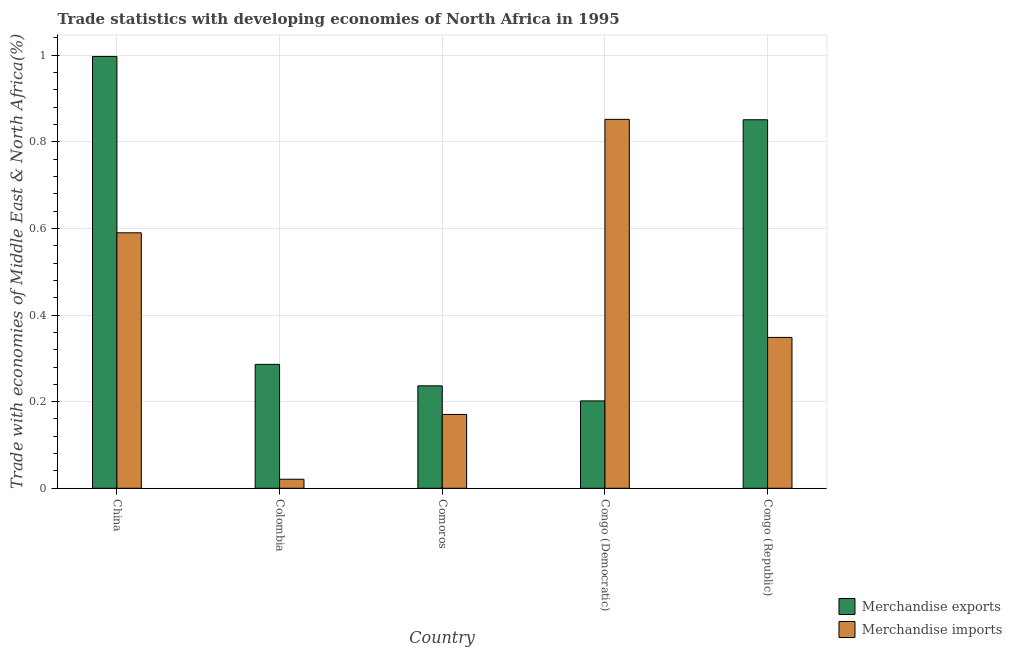How many different coloured bars are there?
Provide a short and direct response. 2. Are the number of bars on each tick of the X-axis equal?
Give a very brief answer. Yes. In how many cases, is the number of bars for a given country not equal to the number of legend labels?
Your answer should be very brief. 0. What is the merchandise exports in Comoros?
Give a very brief answer. 0.24. Across all countries, what is the maximum merchandise imports?
Make the answer very short. 0.85. Across all countries, what is the minimum merchandise imports?
Your answer should be very brief. 0.02. In which country was the merchandise imports maximum?
Provide a succinct answer. Congo (Democratic). In which country was the merchandise exports minimum?
Offer a terse response. Congo (Democratic). What is the total merchandise exports in the graph?
Ensure brevity in your answer.  2.57. What is the difference between the merchandise imports in China and that in Congo (Republic)?
Give a very brief answer. 0.24. What is the difference between the merchandise imports in Comoros and the merchandise exports in Congo (Democratic)?
Your answer should be compact. -0.03. What is the average merchandise imports per country?
Offer a very short reply. 0.4. What is the difference between the merchandise imports and merchandise exports in Congo (Republic)?
Your response must be concise. -0.5. In how many countries, is the merchandise imports greater than 0.6400000000000001 %?
Give a very brief answer. 1. What is the ratio of the merchandise imports in Comoros to that in Congo (Democratic)?
Your answer should be compact. 0.2. Is the merchandise imports in Colombia less than that in Congo (Republic)?
Your answer should be compact. Yes. Is the difference between the merchandise exports in Congo (Democratic) and Congo (Republic) greater than the difference between the merchandise imports in Congo (Democratic) and Congo (Republic)?
Your answer should be compact. No. What is the difference between the highest and the second highest merchandise exports?
Keep it short and to the point. 0.15. What is the difference between the highest and the lowest merchandise imports?
Your answer should be compact. 0.83. In how many countries, is the merchandise exports greater than the average merchandise exports taken over all countries?
Offer a very short reply. 2. Is the sum of the merchandise imports in Colombia and Congo (Republic) greater than the maximum merchandise exports across all countries?
Your response must be concise. No. What does the 2nd bar from the right in China represents?
Make the answer very short. Merchandise exports. How many bars are there?
Provide a short and direct response. 10. What is the difference between two consecutive major ticks on the Y-axis?
Your response must be concise. 0.2. Are the values on the major ticks of Y-axis written in scientific E-notation?
Provide a succinct answer. No. Does the graph contain grids?
Ensure brevity in your answer.  Yes. How are the legend labels stacked?
Your answer should be compact. Vertical. What is the title of the graph?
Provide a succinct answer. Trade statistics with developing economies of North Africa in 1995. What is the label or title of the Y-axis?
Offer a terse response. Trade with economies of Middle East & North Africa(%). What is the Trade with economies of Middle East & North Africa(%) in Merchandise exports in China?
Offer a very short reply. 1. What is the Trade with economies of Middle East & North Africa(%) of Merchandise imports in China?
Provide a short and direct response. 0.59. What is the Trade with economies of Middle East & North Africa(%) of Merchandise exports in Colombia?
Your response must be concise. 0.29. What is the Trade with economies of Middle East & North Africa(%) of Merchandise imports in Colombia?
Your answer should be compact. 0.02. What is the Trade with economies of Middle East & North Africa(%) of Merchandise exports in Comoros?
Offer a terse response. 0.24. What is the Trade with economies of Middle East & North Africa(%) of Merchandise imports in Comoros?
Offer a terse response. 0.17. What is the Trade with economies of Middle East & North Africa(%) in Merchandise exports in Congo (Democratic)?
Make the answer very short. 0.2. What is the Trade with economies of Middle East & North Africa(%) of Merchandise imports in Congo (Democratic)?
Make the answer very short. 0.85. What is the Trade with economies of Middle East & North Africa(%) of Merchandise exports in Congo (Republic)?
Offer a very short reply. 0.85. What is the Trade with economies of Middle East & North Africa(%) in Merchandise imports in Congo (Republic)?
Offer a terse response. 0.35. Across all countries, what is the maximum Trade with economies of Middle East & North Africa(%) of Merchandise exports?
Your response must be concise. 1. Across all countries, what is the maximum Trade with economies of Middle East & North Africa(%) of Merchandise imports?
Your answer should be compact. 0.85. Across all countries, what is the minimum Trade with economies of Middle East & North Africa(%) of Merchandise exports?
Give a very brief answer. 0.2. Across all countries, what is the minimum Trade with economies of Middle East & North Africa(%) of Merchandise imports?
Offer a terse response. 0.02. What is the total Trade with economies of Middle East & North Africa(%) of Merchandise exports in the graph?
Keep it short and to the point. 2.57. What is the total Trade with economies of Middle East & North Africa(%) of Merchandise imports in the graph?
Provide a short and direct response. 1.98. What is the difference between the Trade with economies of Middle East & North Africa(%) of Merchandise exports in China and that in Colombia?
Keep it short and to the point. 0.71. What is the difference between the Trade with economies of Middle East & North Africa(%) of Merchandise imports in China and that in Colombia?
Your answer should be compact. 0.57. What is the difference between the Trade with economies of Middle East & North Africa(%) of Merchandise exports in China and that in Comoros?
Offer a very short reply. 0.76. What is the difference between the Trade with economies of Middle East & North Africa(%) in Merchandise imports in China and that in Comoros?
Give a very brief answer. 0.42. What is the difference between the Trade with economies of Middle East & North Africa(%) in Merchandise exports in China and that in Congo (Democratic)?
Provide a succinct answer. 0.8. What is the difference between the Trade with economies of Middle East & North Africa(%) of Merchandise imports in China and that in Congo (Democratic)?
Give a very brief answer. -0.26. What is the difference between the Trade with economies of Middle East & North Africa(%) of Merchandise exports in China and that in Congo (Republic)?
Ensure brevity in your answer.  0.15. What is the difference between the Trade with economies of Middle East & North Africa(%) of Merchandise imports in China and that in Congo (Republic)?
Ensure brevity in your answer.  0.24. What is the difference between the Trade with economies of Middle East & North Africa(%) of Merchandise exports in Colombia and that in Comoros?
Keep it short and to the point. 0.05. What is the difference between the Trade with economies of Middle East & North Africa(%) of Merchandise imports in Colombia and that in Comoros?
Provide a short and direct response. -0.15. What is the difference between the Trade with economies of Middle East & North Africa(%) in Merchandise exports in Colombia and that in Congo (Democratic)?
Keep it short and to the point. 0.08. What is the difference between the Trade with economies of Middle East & North Africa(%) of Merchandise imports in Colombia and that in Congo (Democratic)?
Offer a terse response. -0.83. What is the difference between the Trade with economies of Middle East & North Africa(%) of Merchandise exports in Colombia and that in Congo (Republic)?
Provide a short and direct response. -0.56. What is the difference between the Trade with economies of Middle East & North Africa(%) of Merchandise imports in Colombia and that in Congo (Republic)?
Provide a short and direct response. -0.33. What is the difference between the Trade with economies of Middle East & North Africa(%) of Merchandise exports in Comoros and that in Congo (Democratic)?
Your response must be concise. 0.03. What is the difference between the Trade with economies of Middle East & North Africa(%) in Merchandise imports in Comoros and that in Congo (Democratic)?
Offer a terse response. -0.68. What is the difference between the Trade with economies of Middle East & North Africa(%) in Merchandise exports in Comoros and that in Congo (Republic)?
Make the answer very short. -0.61. What is the difference between the Trade with economies of Middle East & North Africa(%) in Merchandise imports in Comoros and that in Congo (Republic)?
Offer a very short reply. -0.18. What is the difference between the Trade with economies of Middle East & North Africa(%) of Merchandise exports in Congo (Democratic) and that in Congo (Republic)?
Provide a short and direct response. -0.65. What is the difference between the Trade with economies of Middle East & North Africa(%) of Merchandise imports in Congo (Democratic) and that in Congo (Republic)?
Keep it short and to the point. 0.5. What is the difference between the Trade with economies of Middle East & North Africa(%) of Merchandise exports in China and the Trade with economies of Middle East & North Africa(%) of Merchandise imports in Colombia?
Provide a short and direct response. 0.98. What is the difference between the Trade with economies of Middle East & North Africa(%) of Merchandise exports in China and the Trade with economies of Middle East & North Africa(%) of Merchandise imports in Comoros?
Give a very brief answer. 0.83. What is the difference between the Trade with economies of Middle East & North Africa(%) of Merchandise exports in China and the Trade with economies of Middle East & North Africa(%) of Merchandise imports in Congo (Democratic)?
Make the answer very short. 0.15. What is the difference between the Trade with economies of Middle East & North Africa(%) in Merchandise exports in China and the Trade with economies of Middle East & North Africa(%) in Merchandise imports in Congo (Republic)?
Your response must be concise. 0.65. What is the difference between the Trade with economies of Middle East & North Africa(%) in Merchandise exports in Colombia and the Trade with economies of Middle East & North Africa(%) in Merchandise imports in Comoros?
Keep it short and to the point. 0.12. What is the difference between the Trade with economies of Middle East & North Africa(%) of Merchandise exports in Colombia and the Trade with economies of Middle East & North Africa(%) of Merchandise imports in Congo (Democratic)?
Provide a short and direct response. -0.57. What is the difference between the Trade with economies of Middle East & North Africa(%) of Merchandise exports in Colombia and the Trade with economies of Middle East & North Africa(%) of Merchandise imports in Congo (Republic)?
Ensure brevity in your answer.  -0.06. What is the difference between the Trade with economies of Middle East & North Africa(%) of Merchandise exports in Comoros and the Trade with economies of Middle East & North Africa(%) of Merchandise imports in Congo (Democratic)?
Provide a short and direct response. -0.62. What is the difference between the Trade with economies of Middle East & North Africa(%) of Merchandise exports in Comoros and the Trade with economies of Middle East & North Africa(%) of Merchandise imports in Congo (Republic)?
Provide a short and direct response. -0.11. What is the difference between the Trade with economies of Middle East & North Africa(%) in Merchandise exports in Congo (Democratic) and the Trade with economies of Middle East & North Africa(%) in Merchandise imports in Congo (Republic)?
Offer a terse response. -0.15. What is the average Trade with economies of Middle East & North Africa(%) of Merchandise exports per country?
Keep it short and to the point. 0.51. What is the average Trade with economies of Middle East & North Africa(%) in Merchandise imports per country?
Keep it short and to the point. 0.4. What is the difference between the Trade with economies of Middle East & North Africa(%) in Merchandise exports and Trade with economies of Middle East & North Africa(%) in Merchandise imports in China?
Offer a very short reply. 0.41. What is the difference between the Trade with economies of Middle East & North Africa(%) in Merchandise exports and Trade with economies of Middle East & North Africa(%) in Merchandise imports in Colombia?
Offer a terse response. 0.27. What is the difference between the Trade with economies of Middle East & North Africa(%) of Merchandise exports and Trade with economies of Middle East & North Africa(%) of Merchandise imports in Comoros?
Make the answer very short. 0.07. What is the difference between the Trade with economies of Middle East & North Africa(%) of Merchandise exports and Trade with economies of Middle East & North Africa(%) of Merchandise imports in Congo (Democratic)?
Provide a short and direct response. -0.65. What is the difference between the Trade with economies of Middle East & North Africa(%) of Merchandise exports and Trade with economies of Middle East & North Africa(%) of Merchandise imports in Congo (Republic)?
Offer a terse response. 0.5. What is the ratio of the Trade with economies of Middle East & North Africa(%) of Merchandise exports in China to that in Colombia?
Your response must be concise. 3.48. What is the ratio of the Trade with economies of Middle East & North Africa(%) of Merchandise imports in China to that in Colombia?
Offer a terse response. 28.28. What is the ratio of the Trade with economies of Middle East & North Africa(%) of Merchandise exports in China to that in Comoros?
Ensure brevity in your answer.  4.21. What is the ratio of the Trade with economies of Middle East & North Africa(%) in Merchandise imports in China to that in Comoros?
Your answer should be compact. 3.46. What is the ratio of the Trade with economies of Middle East & North Africa(%) of Merchandise exports in China to that in Congo (Democratic)?
Your answer should be very brief. 4.94. What is the ratio of the Trade with economies of Middle East & North Africa(%) of Merchandise imports in China to that in Congo (Democratic)?
Your answer should be very brief. 0.69. What is the ratio of the Trade with economies of Middle East & North Africa(%) of Merchandise exports in China to that in Congo (Republic)?
Your answer should be very brief. 1.17. What is the ratio of the Trade with economies of Middle East & North Africa(%) in Merchandise imports in China to that in Congo (Republic)?
Keep it short and to the point. 1.69. What is the ratio of the Trade with economies of Middle East & North Africa(%) in Merchandise exports in Colombia to that in Comoros?
Offer a very short reply. 1.21. What is the ratio of the Trade with economies of Middle East & North Africa(%) in Merchandise imports in Colombia to that in Comoros?
Keep it short and to the point. 0.12. What is the ratio of the Trade with economies of Middle East & North Africa(%) in Merchandise exports in Colombia to that in Congo (Democratic)?
Offer a very short reply. 1.42. What is the ratio of the Trade with economies of Middle East & North Africa(%) of Merchandise imports in Colombia to that in Congo (Democratic)?
Provide a succinct answer. 0.02. What is the ratio of the Trade with economies of Middle East & North Africa(%) in Merchandise exports in Colombia to that in Congo (Republic)?
Offer a terse response. 0.34. What is the ratio of the Trade with economies of Middle East & North Africa(%) of Merchandise imports in Colombia to that in Congo (Republic)?
Offer a very short reply. 0.06. What is the ratio of the Trade with economies of Middle East & North Africa(%) of Merchandise exports in Comoros to that in Congo (Democratic)?
Offer a terse response. 1.17. What is the ratio of the Trade with economies of Middle East & North Africa(%) of Merchandise imports in Comoros to that in Congo (Democratic)?
Your response must be concise. 0.2. What is the ratio of the Trade with economies of Middle East & North Africa(%) of Merchandise exports in Comoros to that in Congo (Republic)?
Your response must be concise. 0.28. What is the ratio of the Trade with economies of Middle East & North Africa(%) in Merchandise imports in Comoros to that in Congo (Republic)?
Keep it short and to the point. 0.49. What is the ratio of the Trade with economies of Middle East & North Africa(%) of Merchandise exports in Congo (Democratic) to that in Congo (Republic)?
Your answer should be very brief. 0.24. What is the ratio of the Trade with economies of Middle East & North Africa(%) of Merchandise imports in Congo (Democratic) to that in Congo (Republic)?
Your response must be concise. 2.45. What is the difference between the highest and the second highest Trade with economies of Middle East & North Africa(%) of Merchandise exports?
Provide a succinct answer. 0.15. What is the difference between the highest and the second highest Trade with economies of Middle East & North Africa(%) of Merchandise imports?
Offer a very short reply. 0.26. What is the difference between the highest and the lowest Trade with economies of Middle East & North Africa(%) of Merchandise exports?
Your answer should be compact. 0.8. What is the difference between the highest and the lowest Trade with economies of Middle East & North Africa(%) in Merchandise imports?
Offer a terse response. 0.83. 